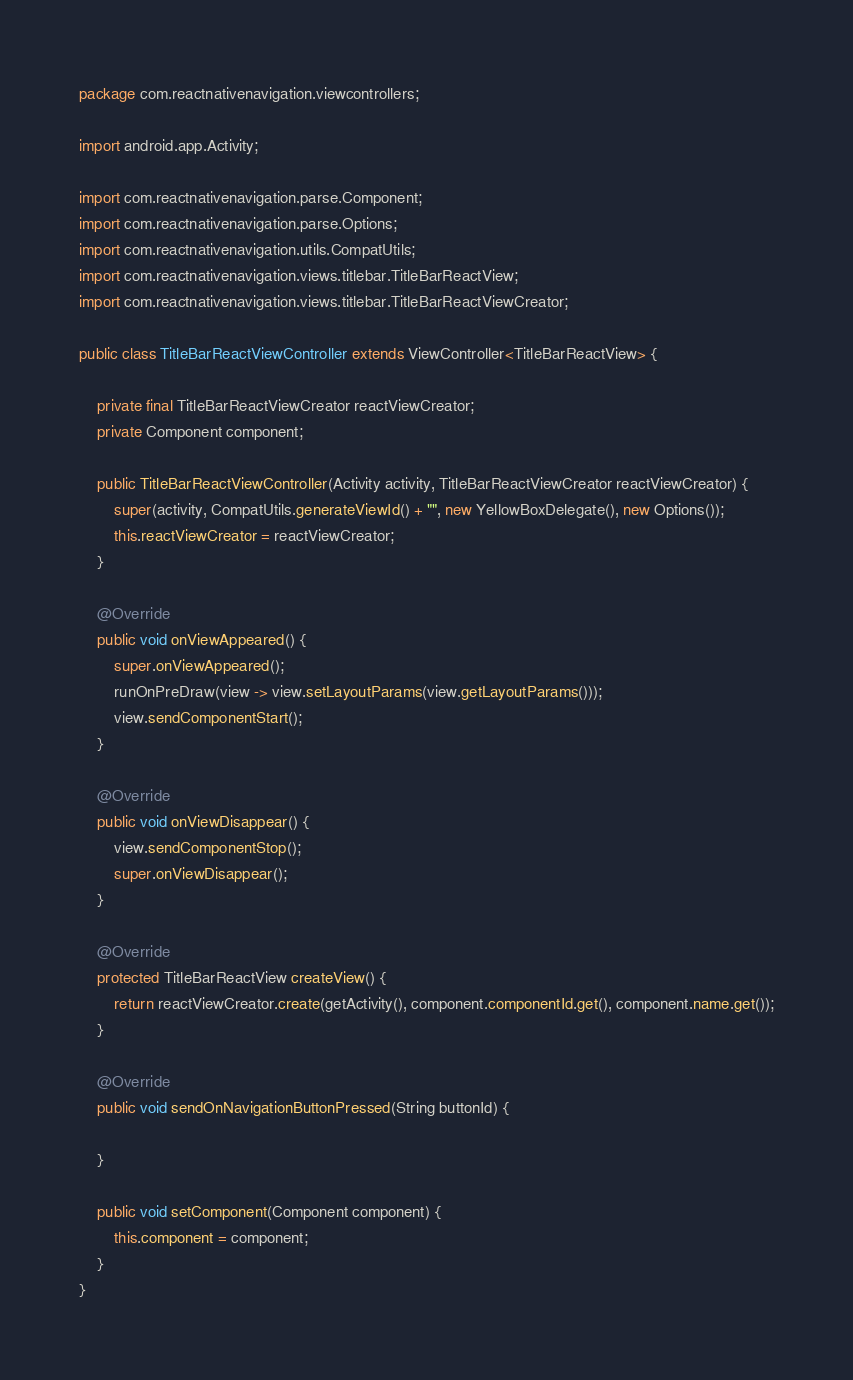Convert code to text. <code><loc_0><loc_0><loc_500><loc_500><_Java_>package com.reactnativenavigation.viewcontrollers;

import android.app.Activity;

import com.reactnativenavigation.parse.Component;
import com.reactnativenavigation.parse.Options;
import com.reactnativenavigation.utils.CompatUtils;
import com.reactnativenavigation.views.titlebar.TitleBarReactView;
import com.reactnativenavigation.views.titlebar.TitleBarReactViewCreator;

public class TitleBarReactViewController extends ViewController<TitleBarReactView> {

    private final TitleBarReactViewCreator reactViewCreator;
    private Component component;

    public TitleBarReactViewController(Activity activity, TitleBarReactViewCreator reactViewCreator) {
        super(activity, CompatUtils.generateViewId() + "", new YellowBoxDelegate(), new Options());
        this.reactViewCreator = reactViewCreator;
    }

    @Override
    public void onViewAppeared() {
        super.onViewAppeared();
        runOnPreDraw(view -> view.setLayoutParams(view.getLayoutParams()));
        view.sendComponentStart();
    }

    @Override
    public void onViewDisappear() {
        view.sendComponentStop();
        super.onViewDisappear();
    }

    @Override
    protected TitleBarReactView createView() {
        return reactViewCreator.create(getActivity(), component.componentId.get(), component.name.get());
    }

    @Override
    public void sendOnNavigationButtonPressed(String buttonId) {

    }

    public void setComponent(Component component) {
        this.component = component;
    }
}
</code> 